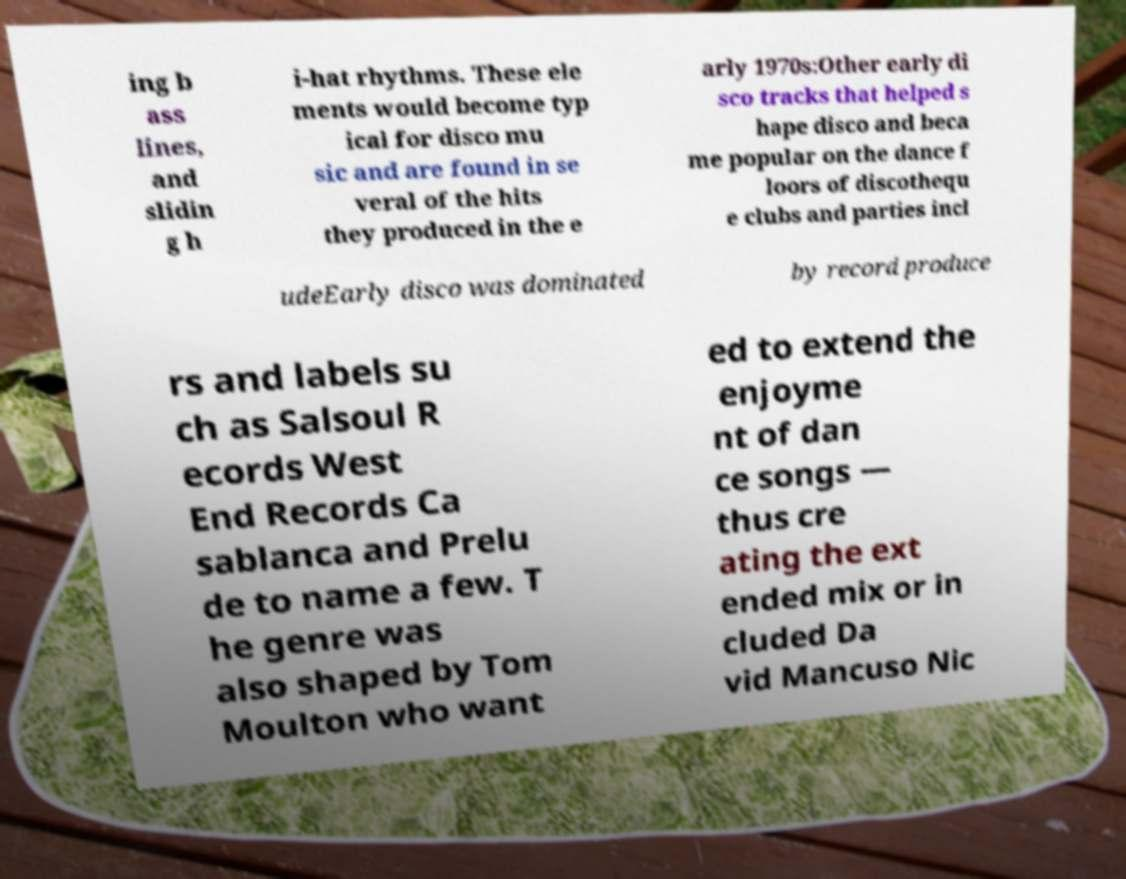Please identify and transcribe the text found in this image. ing b ass lines, and slidin g h i-hat rhythms. These ele ments would become typ ical for disco mu sic and are found in se veral of the hits they produced in the e arly 1970s:Other early di sco tracks that helped s hape disco and beca me popular on the dance f loors of discothequ e clubs and parties incl udeEarly disco was dominated by record produce rs and labels su ch as Salsoul R ecords West End Records Ca sablanca and Prelu de to name a few. T he genre was also shaped by Tom Moulton who want ed to extend the enjoyme nt of dan ce songs — thus cre ating the ext ended mix or in cluded Da vid Mancuso Nic 